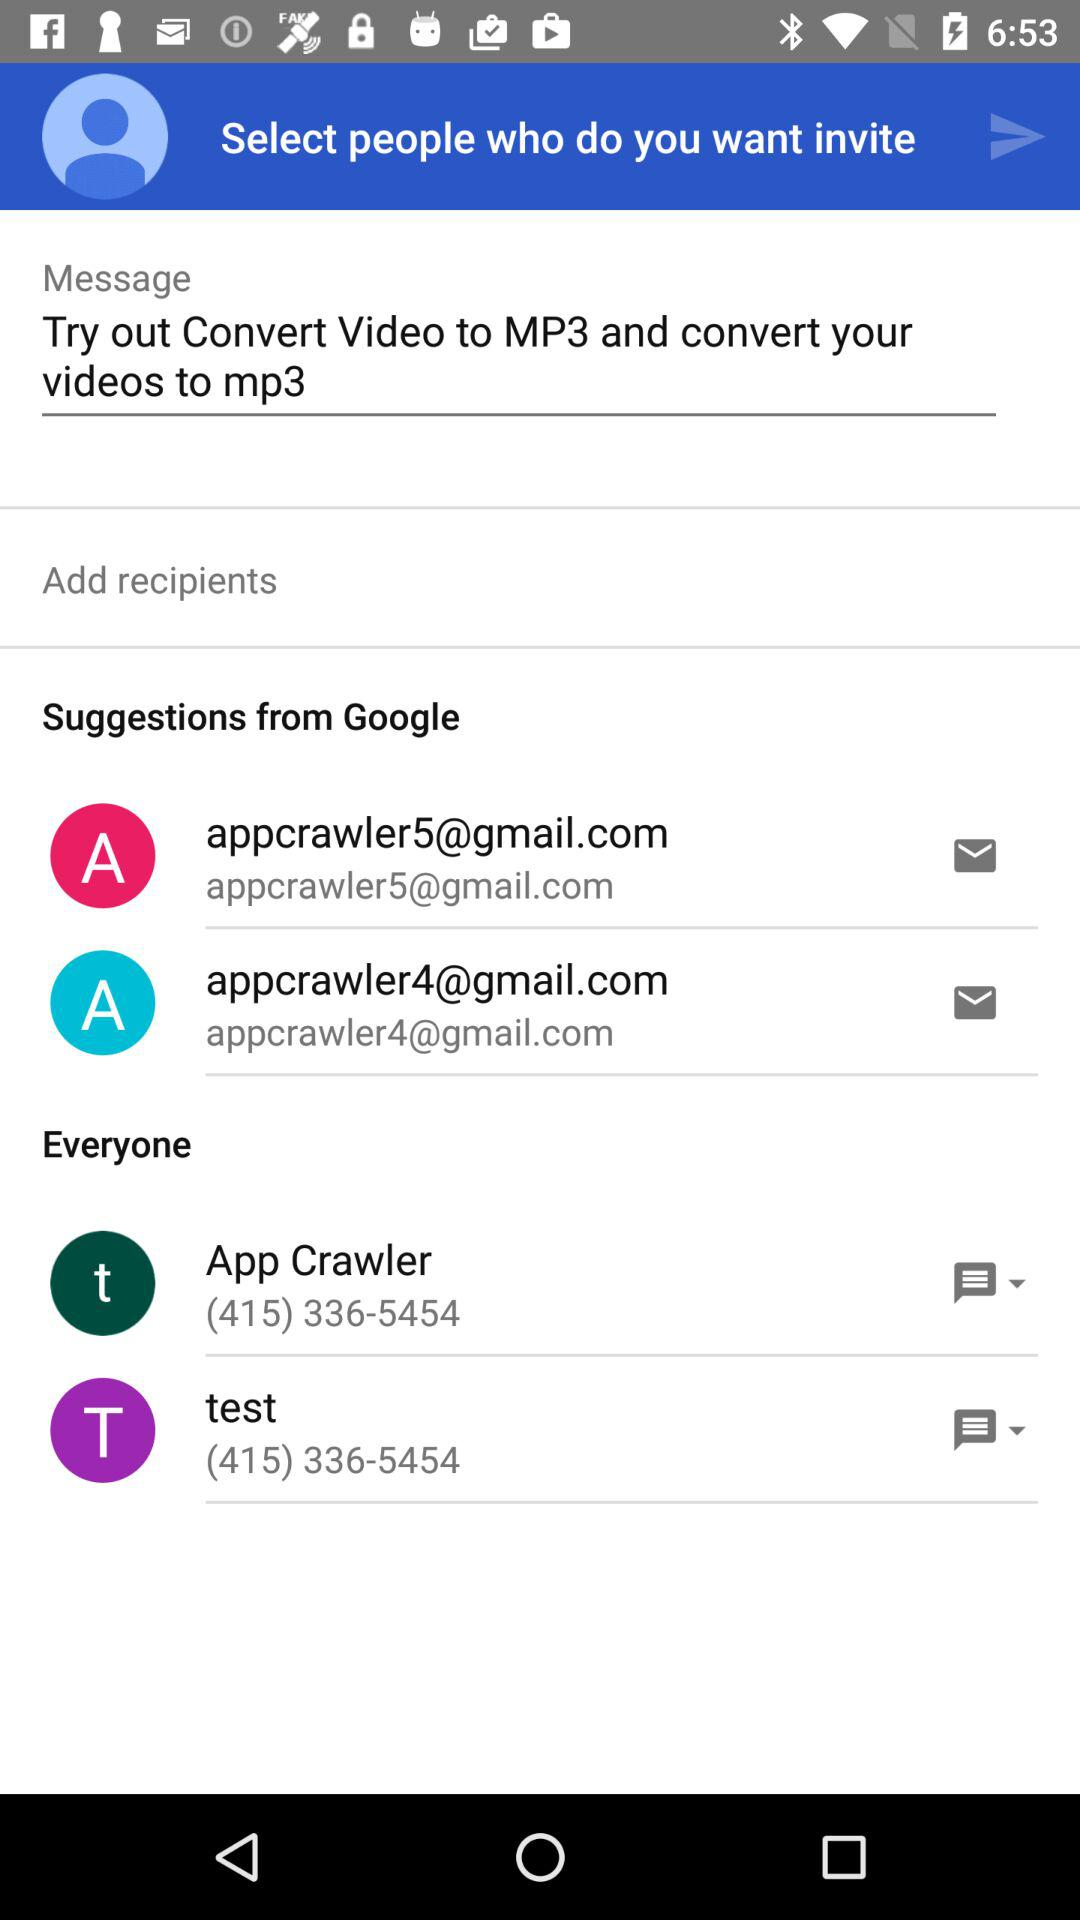What are the suggestions from Google? The suggestions from Google are appcrawler5@gmail.com and appcrawler4@gmail.com. 